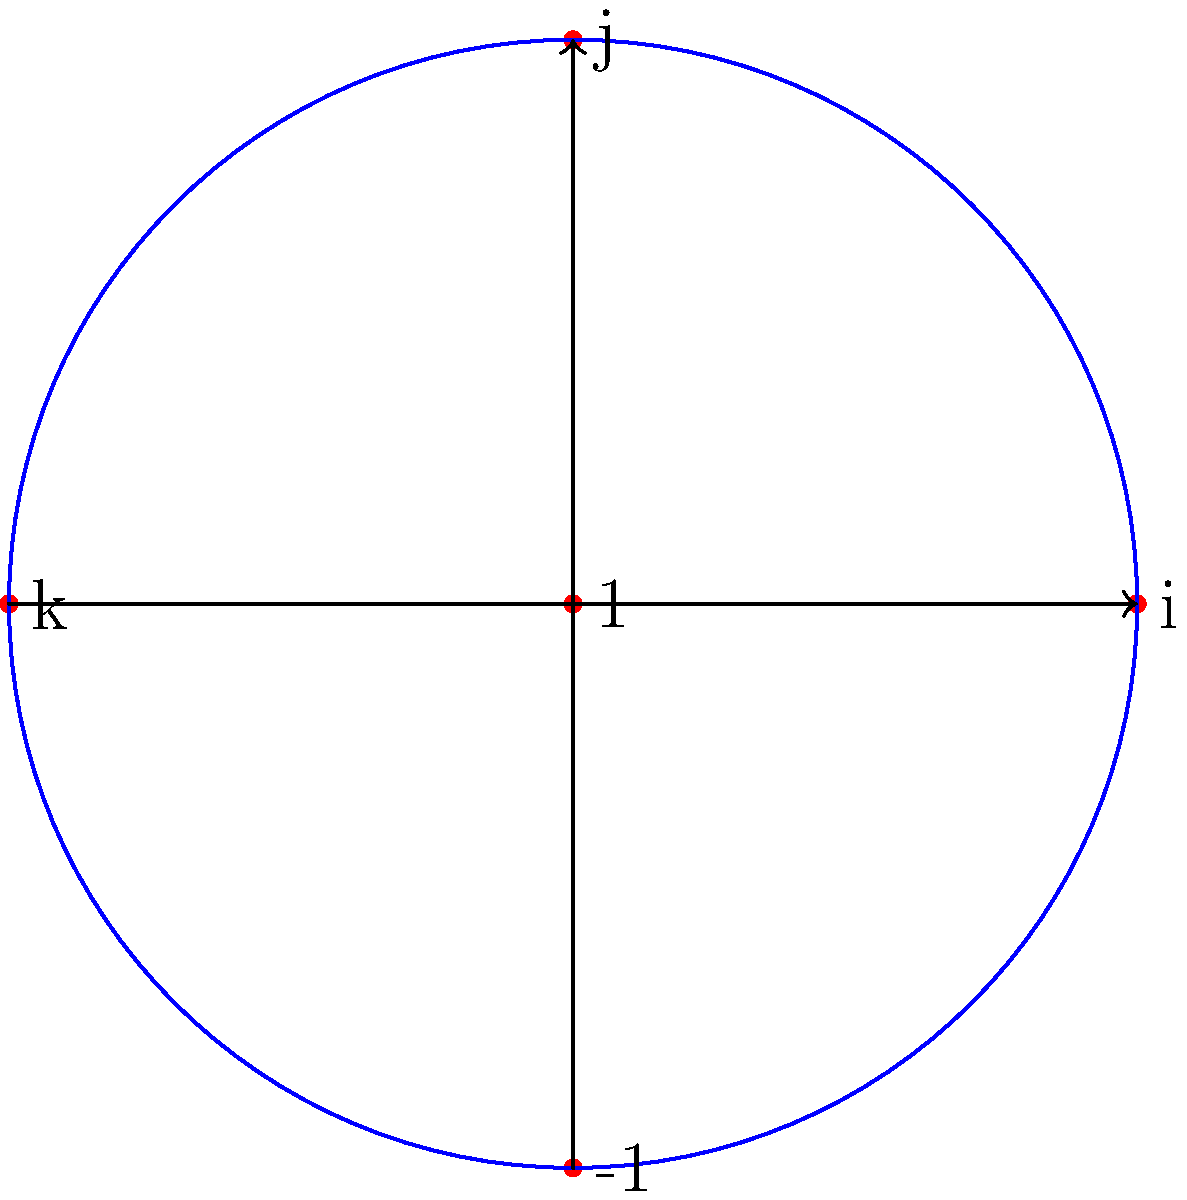В контексте разработки VR/AR приложений, где кватернионы часто используются для представления вращений, рассмотрим кватернионную группу $Q_8$. На диаграмме показаны некоторые элементы $Q_8$. Сколько различных подгрупп порядка 4 существует в $Q_8$? Для ответа на этот вопрос выполним следующие шаги:

1) Вспомним, что кватернионная группа $Q_8$ состоит из 8 элементов: $\{±1, ±i, ±j, ±k\}$

2) Подгруппы порядка 4 должны содержать ровно половину элементов группы $Q_8$.

3) Рассмотрим возможные подгруппы порядка 4:

   a) $\{1, -1, i, -i\}$
   b) $\{1, -1, j, -j\}$
   c) $\{1, -1, k, -k\}$

4) Заметим, что каждая из этих подгрупп изоморфна циклической группе $C_4$.

5) Важно отметить, что других подгрупп порядка 4 в $Q_8$ нет, так как любая подгруппа должна содержать единичный элемент и его обратный (-1), а затем любой из оставшихся элементов и его обратный.

6) Таким образом, мы нашли все возможные подгруппы порядка 4 в $Q_8$.

В контексте VR/AR, понимание структуры кватернионной группы важно для эффективной работы с вращениями и ориентациями объектов в трехмерном пространстве.
Answer: 3 